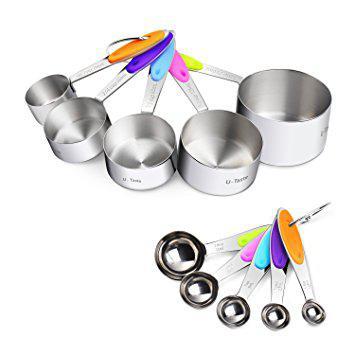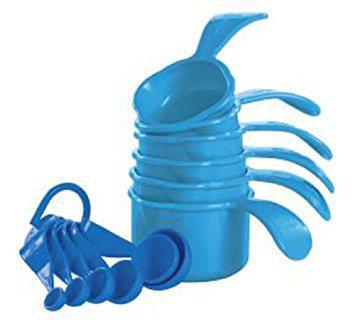The first image is the image on the left, the second image is the image on the right. Analyze the images presented: Is the assertion "One image shows solid color plastic measuring cups and spoons." valid? Answer yes or no. Yes. 